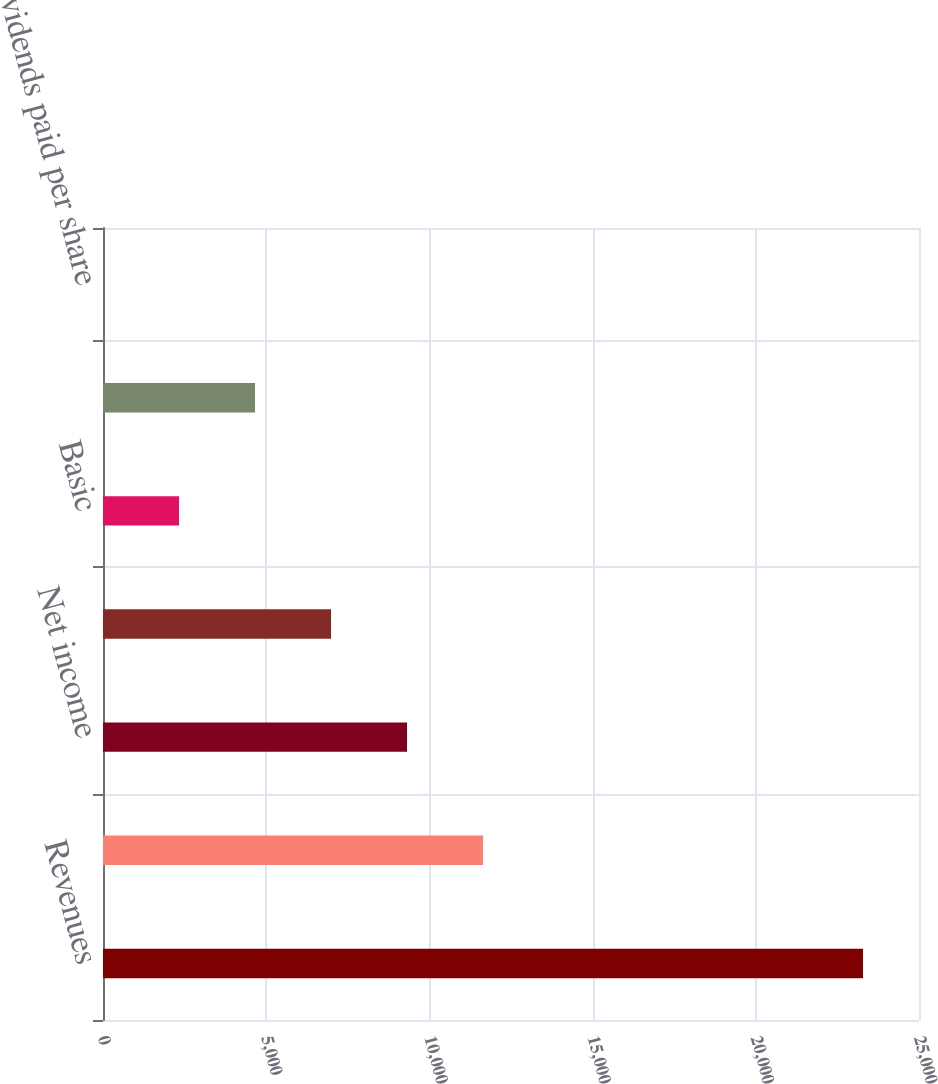Convert chart. <chart><loc_0><loc_0><loc_500><loc_500><bar_chart><fcel>Revenues<fcel>Income from operations<fcel>Net income<fcel>Net income attributable to MPC<fcel>Basic<fcel>Diluted<fcel>Dividends paid per share<nl><fcel>23285<fcel>11642.6<fcel>9314.13<fcel>6985.65<fcel>2328.69<fcel>4657.17<fcel>0.21<nl></chart> 